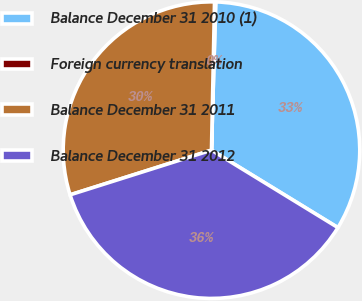Convert chart. <chart><loc_0><loc_0><loc_500><loc_500><pie_chart><fcel>Balance December 31 2010 (1)<fcel>Foreign currency translation<fcel>Balance December 31 2011<fcel>Balance December 31 2012<nl><fcel>33.29%<fcel>0.13%<fcel>30.2%<fcel>36.38%<nl></chart> 